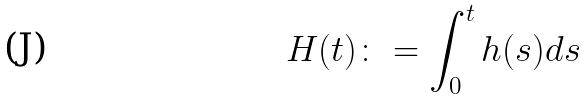<formula> <loc_0><loc_0><loc_500><loc_500>H ( t ) \colon = \int _ { 0 } ^ { t } h ( s ) d s</formula> 